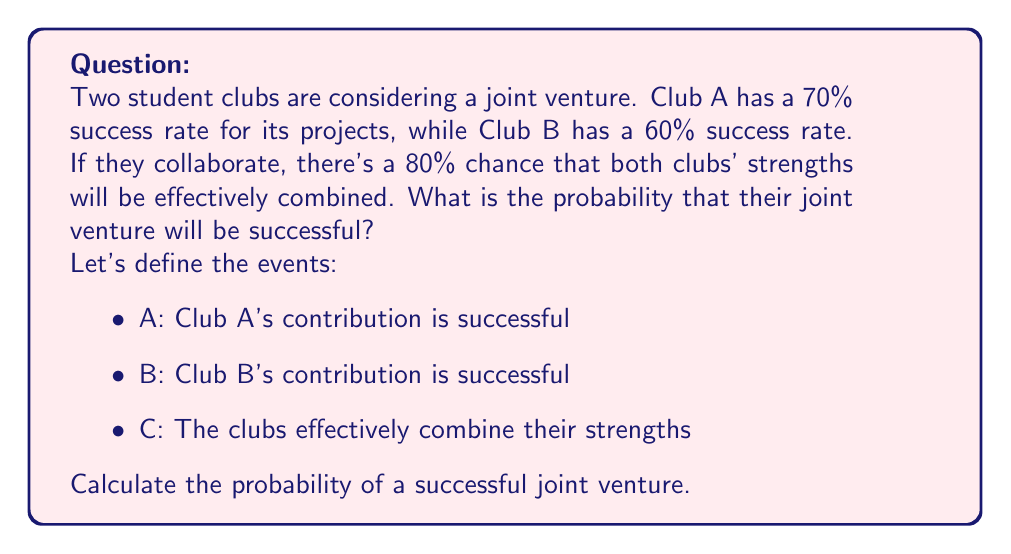What is the answer to this math problem? Let's approach this step-by-step:

1) First, we need to understand what constitutes a successful joint venture. It occurs when:
   - Both clubs' contributions are successful AND they effectively combine their strengths, OR
   - At least one club's contribution is successful when they fail to effectively combine their strengths

2) Let's calculate the probabilities:
   $P(A) = 0.70$
   $P(B) = 0.60$
   $P(C) = 0.80$

3) Probability of both clubs being successful and effectively combining strengths:
   $P(A \cap B \cap C) = P(A) \times P(B) \times P(C) = 0.70 \times 0.60 \times 0.80 = 0.336$

4) Probability of at least one club being successful when they fail to combine strengths:
   $P((A \cup B) \cap \overline{C}) = (P(A) + P(B) - P(A \cap B)) \times P(\overline{C})$
   $= (0.70 + 0.60 - (0.70 \times 0.60)) \times 0.20$
   $= (1.30 - 0.42) \times 0.20 = 0.88 \times 0.20 = 0.176$

5) Total probability of a successful joint venture:
   $P(\text{success}) = P(A \cap B \cap C) + P((A \cup B) \cap \overline{C})$
   $= 0.336 + 0.176 = 0.512$

Therefore, the probability of a successful joint venture is 0.512 or 51.2%.
Answer: 0.512 